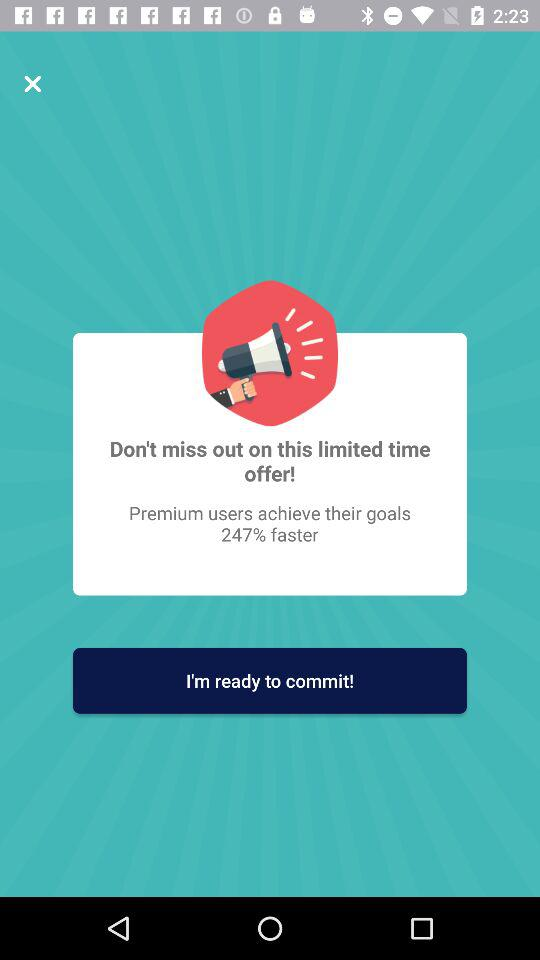How much faster did the user achieve their goals? The user achieved their goals 274% faster. 